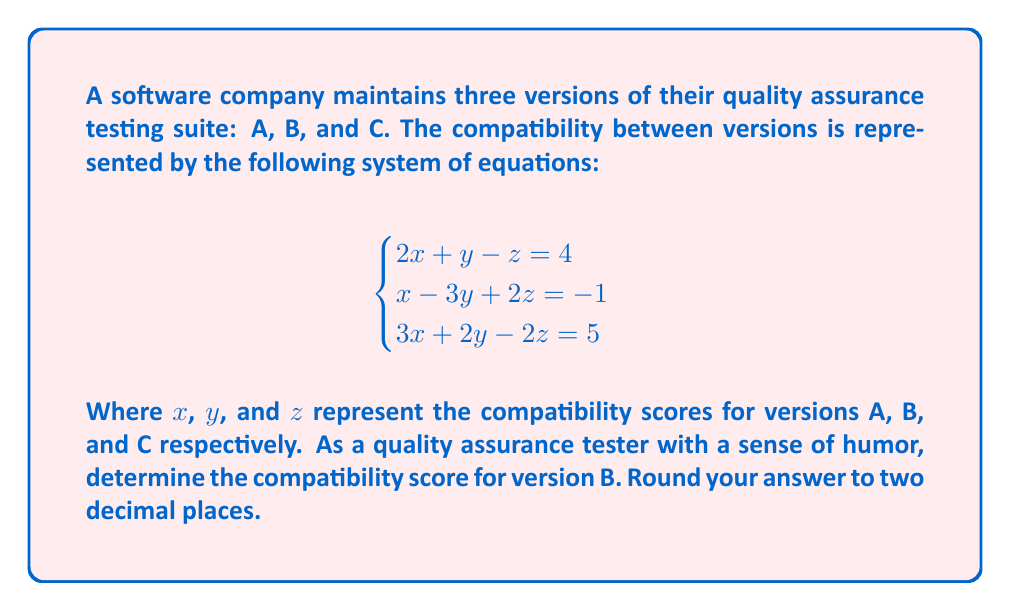Show me your answer to this math problem. Let's solve this system of equations using the elimination method:

1) First, let's eliminate x by multiplying the first equation by 3 and the second equation by -2:

   $$6x + 3y - 3z = 12$$ (Equation 1 * 3)
   $$-2x + 6y - 4z = 2$$ (Equation 2 * -2)

   Adding these equations:
   $$9y - 7z = 14$$ (Equation 4)

2) Now, let's eliminate x between the first and third equations by multiplying the first equation by 3 and the third equation by -2:

   $$6x + 3y - 3z = 12$$ (Equation 1 * 3)
   $$-6x - 4y + 4z = -10$$ (Equation 3 * -2)

   Adding these equations:
   $$-y + z = 2$$ (Equation 5)

3) We now have two equations with two unknowns (y and z):

   $$9y - 7z = 14$$ (Equation 4)
   $$-y + z = 2$$ (Equation 5)

4) Multiply Equation 5 by 9:
   $$-9y + 9z = 18$$ (Equation 6)

5) Add Equation 4 and Equation 6:
   $$2z = 32$$
   $$z = 16$$

6) Substitute this value of z back into Equation 5:
   $$-y + 16 = 2$$
   $$-y = -14$$
   $$y = 14$$

7) We can verify this solution by substituting the values of y and z into any of the original equations to find x, but we don't need to for this question.

Therefore, the compatibility score for version B (represented by y) is 14.
Answer: 14.00 